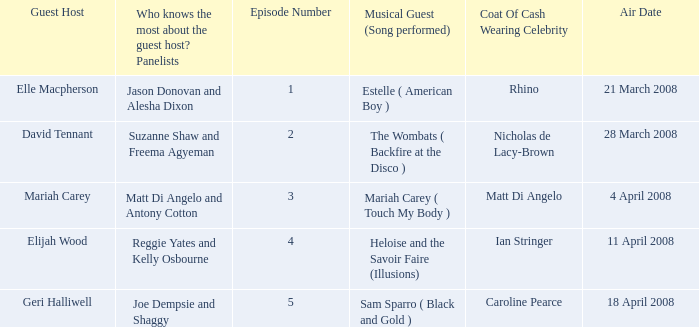Name the total number of episodes for coat of cash wearing celebrity is matt di angelo 1.0. 